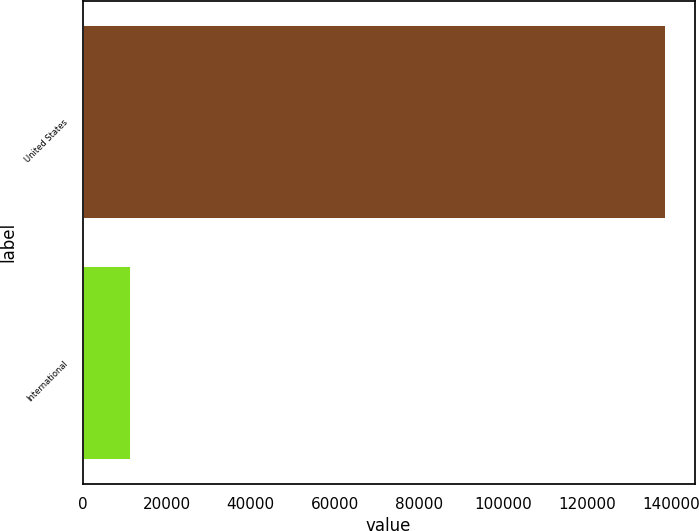Convert chart to OTSL. <chart><loc_0><loc_0><loc_500><loc_500><bar_chart><fcel>United States<fcel>International<nl><fcel>138704<fcel>11171<nl></chart> 